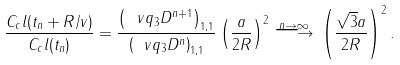Convert formula to latex. <formula><loc_0><loc_0><loc_500><loc_500>\frac { C _ { c } l ( t _ { n } + R / v ) } { C _ { c } l ( t _ { n } ) } = \frac { \left ( \ v q _ { 3 } D ^ { n + 1 } \right ) _ { 1 , 1 } } { \left ( \ v q _ { 3 } D ^ { n } \right ) _ { 1 , 1 } } \left ( \frac { a } { 2 R } \right ) ^ { 2 } \stackrel { n \to \infty } { \longrightarrow } \, \left ( \frac { \sqrt { 3 } a } { 2 R } \right ) ^ { 2 } .</formula> 